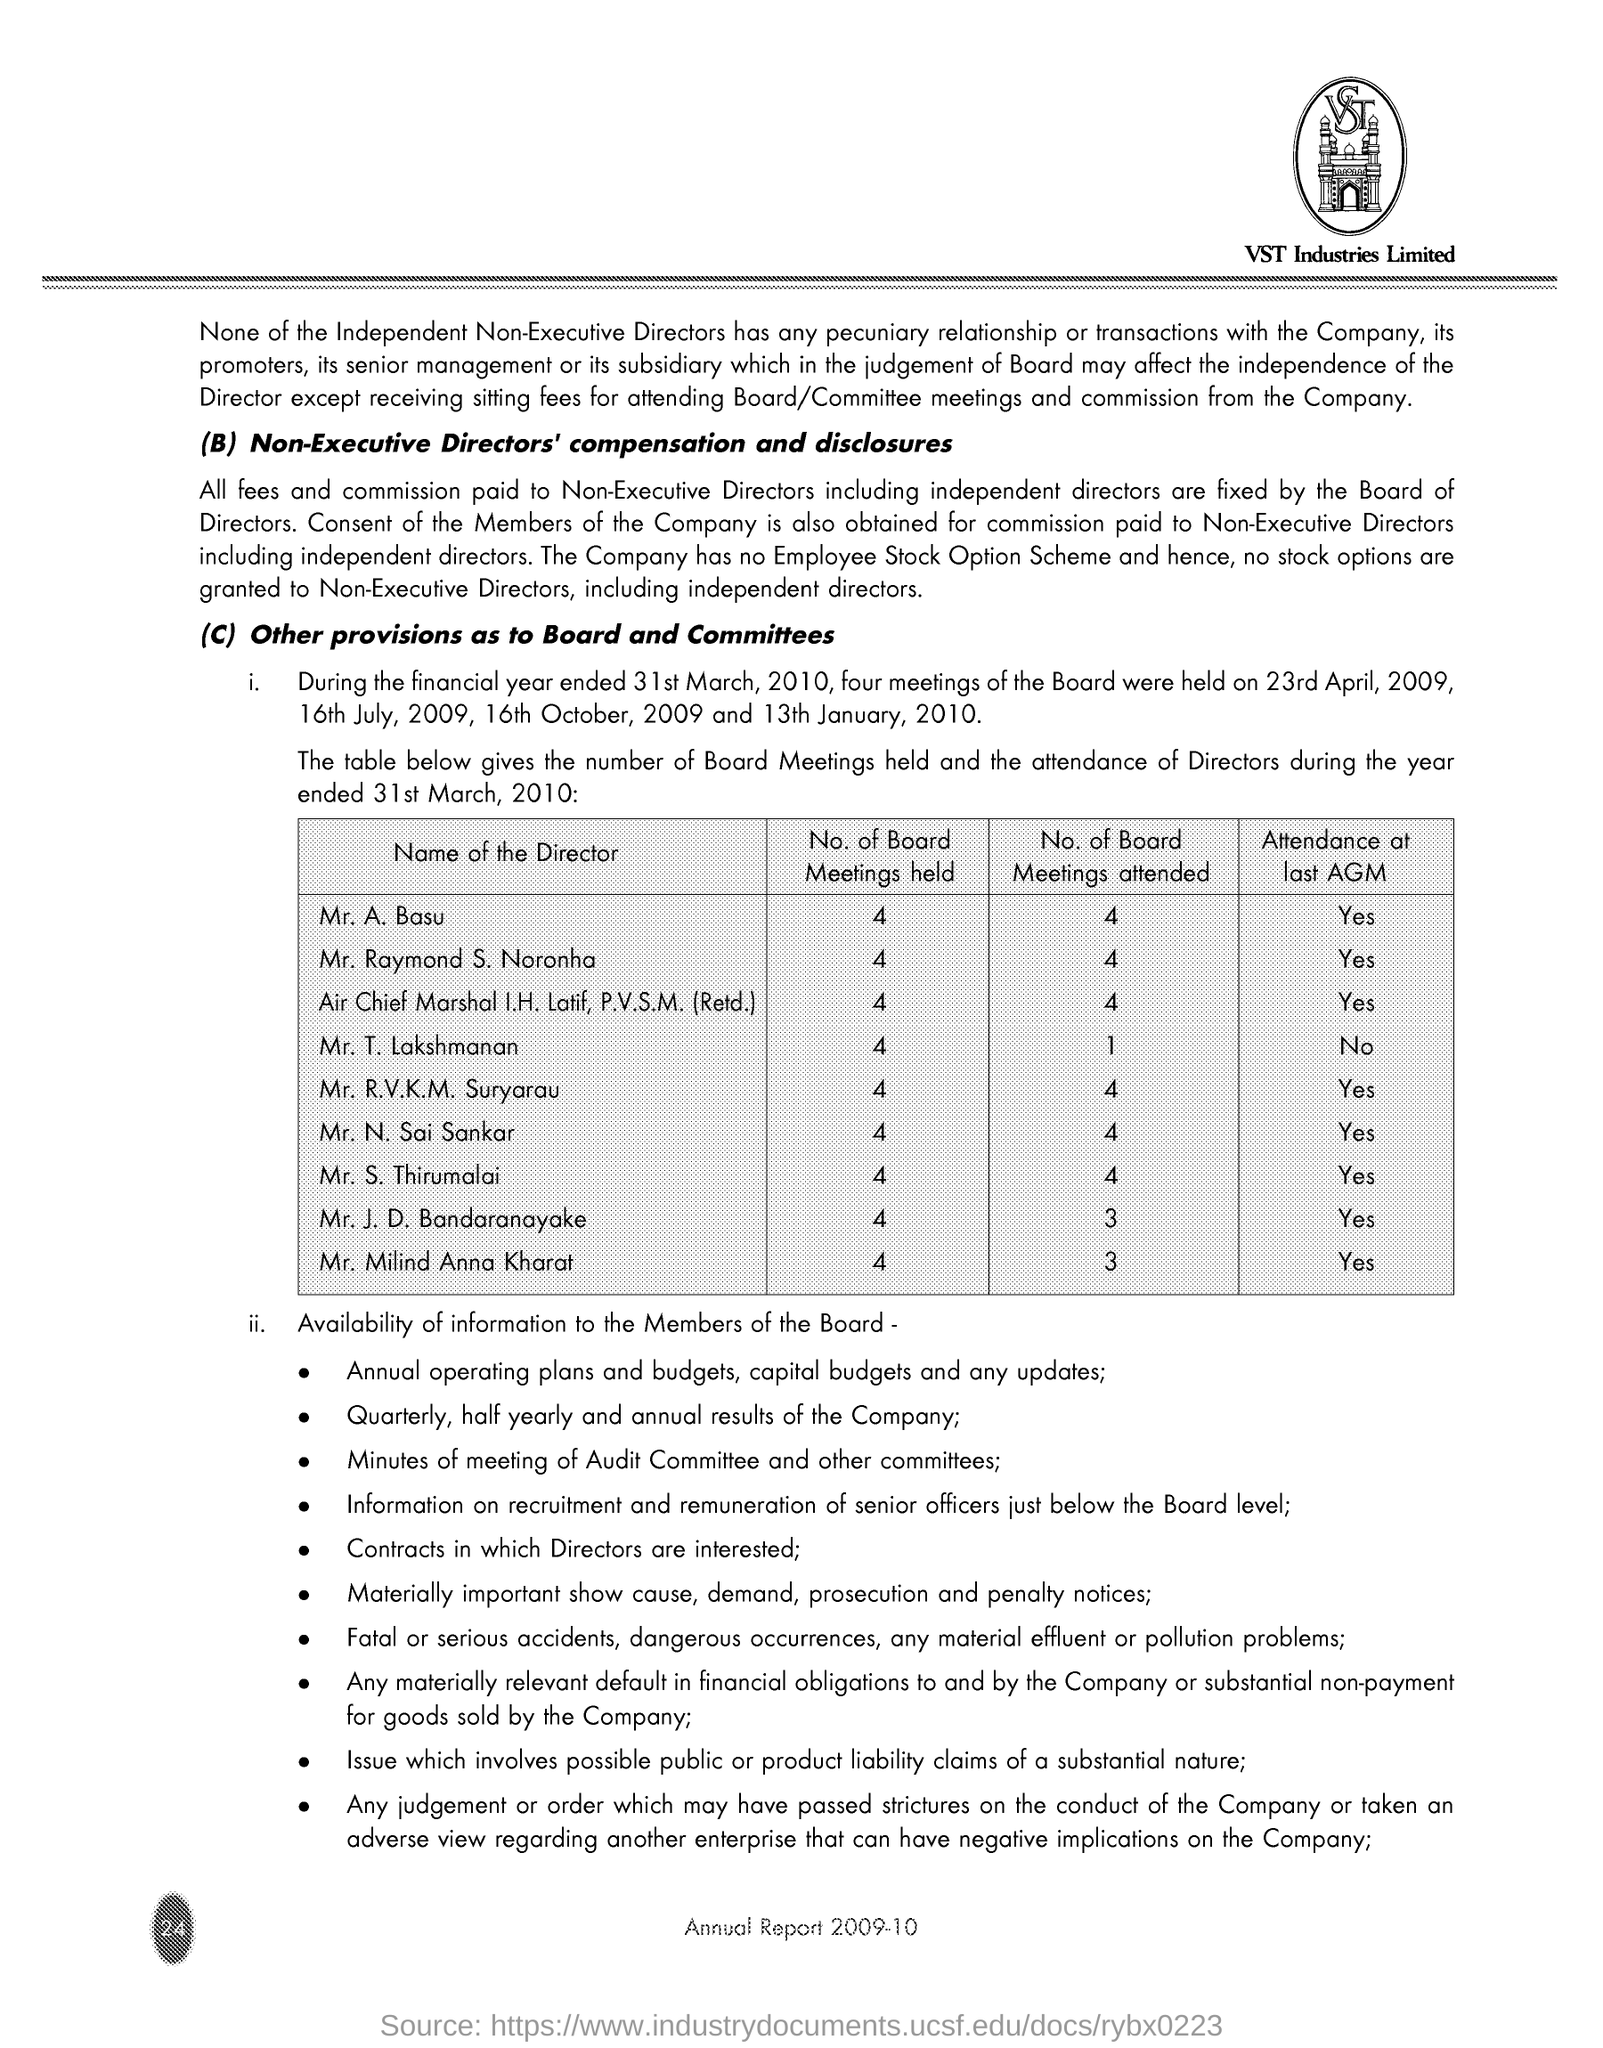What is the Company Name ?
Your response must be concise. VST Industries Limited. 